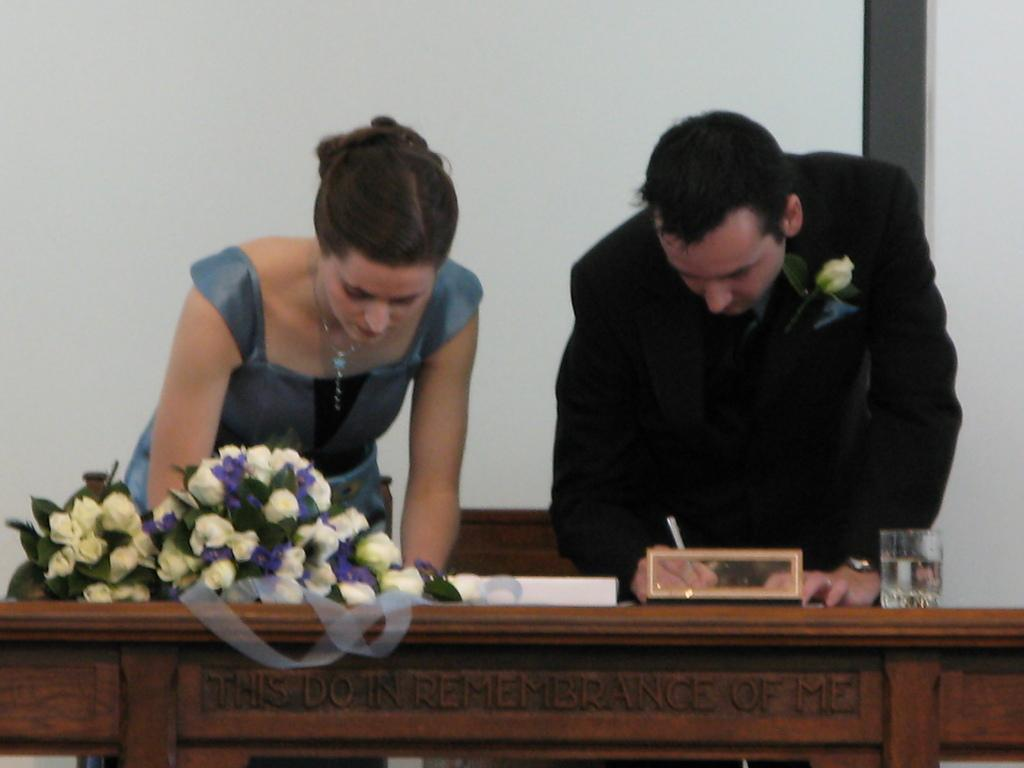Who are the people in the image? There is a woman and a man standing in the image. What can be seen on the table in the image? There is a wooden table in the image, and on it, there is a flower bouquet, a water glass, and a paper. What is the color of the background in the image? The background of the image appears to be white in color. What type of ball is being used to measure the height of the chalk in the image? There is no ball, measurement, or chalk present in the image. 